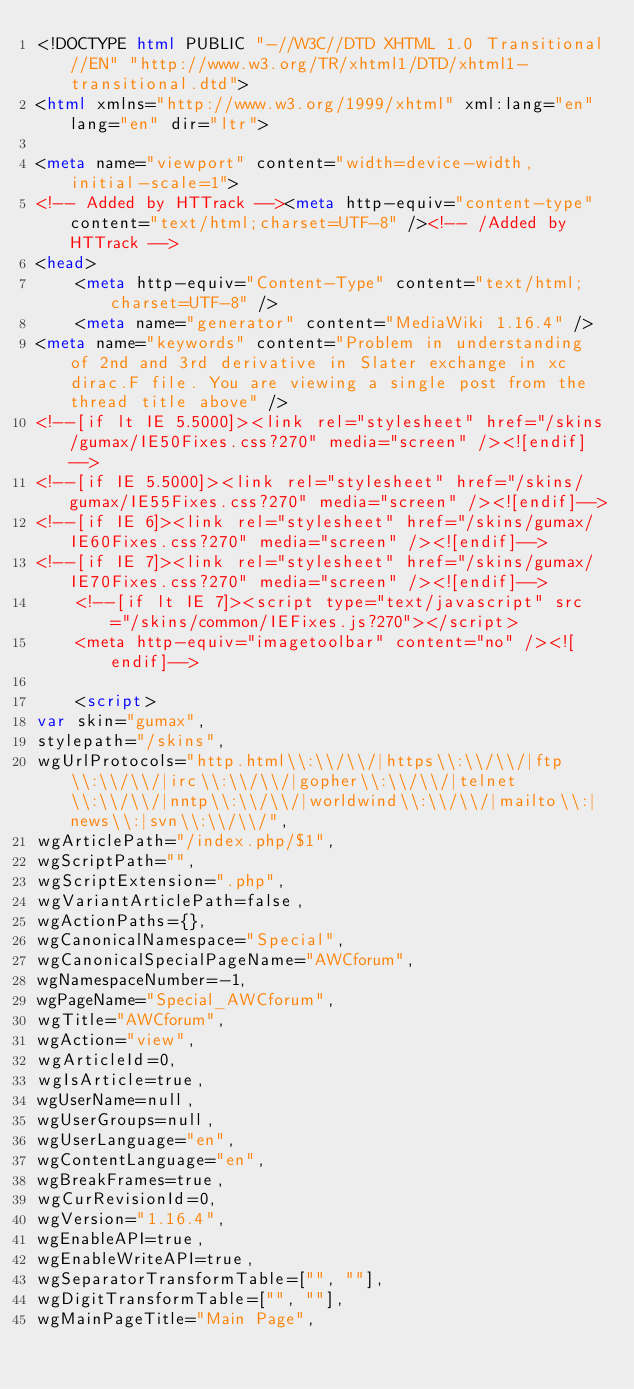<code> <loc_0><loc_0><loc_500><loc_500><_HTML_><!DOCTYPE html PUBLIC "-//W3C//DTD XHTML 1.0 Transitional//EN" "http://www.w3.org/TR/xhtml1/DTD/xhtml1-transitional.dtd">
<html xmlns="http://www.w3.org/1999/xhtml" xml:lang="en" lang="en" dir="ltr">
	
<meta name="viewport" content="width=device-width, initial-scale=1">
<!-- Added by HTTrack --><meta http-equiv="content-type" content="text/html;charset=UTF-8" /><!-- /Added by HTTrack -->
<head>
		<meta http-equiv="Content-Type" content="text/html; charset=UTF-8" />
		<meta name="generator" content="MediaWiki 1.16.4" />
<meta name="keywords" content="Problem in understanding of 2nd and 3rd derivative in Slater exchange in xc dirac.F file. You are viewing a single post from the thread title above" />
<!--[if lt IE 5.5000]><link rel="stylesheet" href="/skins/gumax/IE50Fixes.css?270" media="screen" /><![endif]-->
<!--[if IE 5.5000]><link rel="stylesheet" href="/skins/gumax/IE55Fixes.css?270" media="screen" /><![endif]-->
<!--[if IE 6]><link rel="stylesheet" href="/skins/gumax/IE60Fixes.css?270" media="screen" /><![endif]-->
<!--[if IE 7]><link rel="stylesheet" href="/skins/gumax/IE70Fixes.css?270" media="screen" /><![endif]-->
		<!--[if lt IE 7]><script type="text/javascript" src="/skins/common/IEFixes.js?270"></script>
		<meta http-equiv="imagetoolbar" content="no" /><![endif]-->

		<script>
var skin="gumax",
stylepath="/skins",
wgUrlProtocols="http.html\\:\\/\\/|https\\:\\/\\/|ftp\\:\\/\\/|irc\\:\\/\\/|gopher\\:\\/\\/|telnet\\:\\/\\/|nntp\\:\\/\\/|worldwind\\:\\/\\/|mailto\\:|news\\:|svn\\:\\/\\/",
wgArticlePath="/index.php/$1",
wgScriptPath="",
wgScriptExtension=".php",
wgVariantArticlePath=false,
wgActionPaths={},
wgCanonicalNamespace="Special",
wgCanonicalSpecialPageName="AWCforum",
wgNamespaceNumber=-1,
wgPageName="Special_AWCforum",
wgTitle="AWCforum",
wgAction="view",
wgArticleId=0,
wgIsArticle=true,
wgUserName=null,
wgUserGroups=null,
wgUserLanguage="en",
wgContentLanguage="en",
wgBreakFrames=true,
wgCurRevisionId=0,
wgVersion="1.16.4",
wgEnableAPI=true,
wgEnableWriteAPI=true,
wgSeparatorTransformTable=["", ""],
wgDigitTransformTable=["", ""],
wgMainPageTitle="Main Page",</code> 